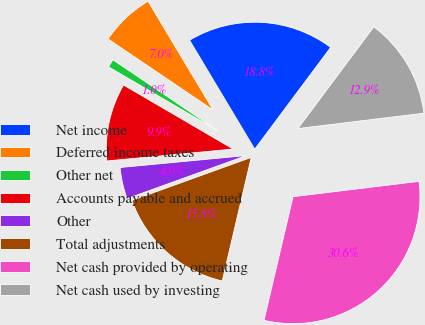<chart> <loc_0><loc_0><loc_500><loc_500><pie_chart><fcel>Net income<fcel>Deferred income taxes<fcel>Other net<fcel>Accounts payable and accrued<fcel>Other<fcel>Total adjustments<fcel>Net cash provided by operating<fcel>Net cash used by investing<nl><fcel>18.78%<fcel>6.96%<fcel>1.05%<fcel>9.91%<fcel>4.01%<fcel>15.82%<fcel>30.6%<fcel>12.87%<nl></chart> 